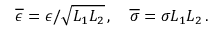Convert formula to latex. <formula><loc_0><loc_0><loc_500><loc_500>\overline { \epsilon } = \epsilon / \sqrt { L _ { 1 } L _ { 2 } } \, , \quad \overline { \sigma } = \sigma L _ { 1 } L _ { 2 } \, .</formula> 